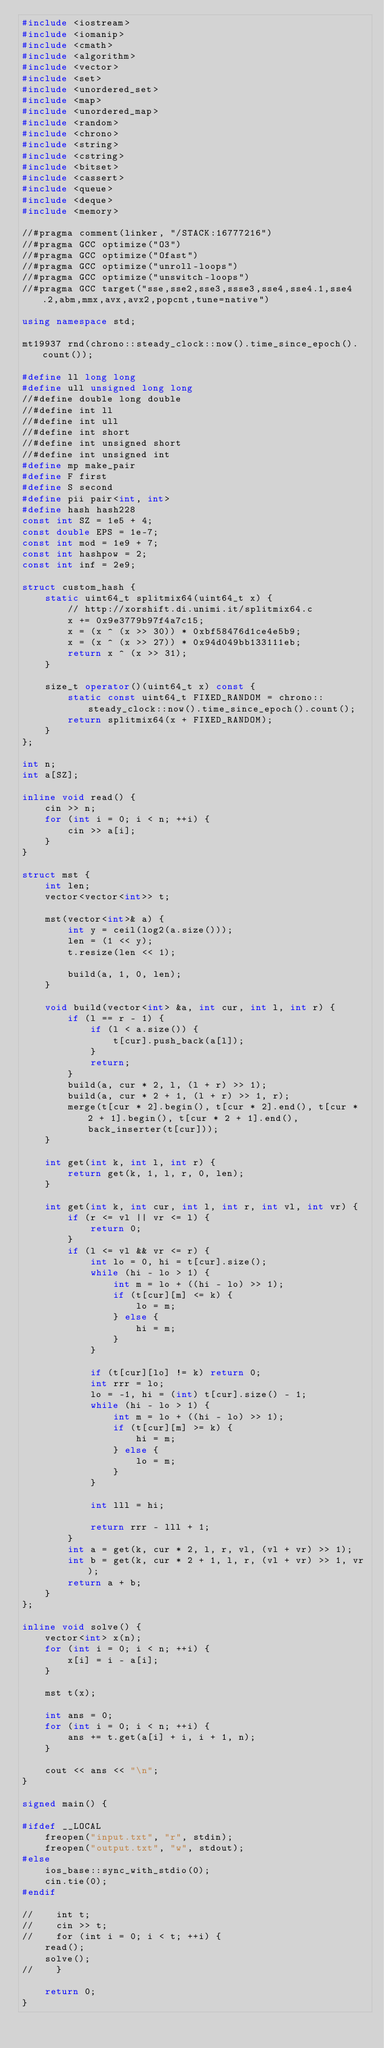<code> <loc_0><loc_0><loc_500><loc_500><_C++_>#include <iostream>
#include <iomanip>
#include <cmath>
#include <algorithm>
#include <vector>
#include <set>
#include <unordered_set>
#include <map>
#include <unordered_map>
#include <random>
#include <chrono>
#include <string>
#include <cstring>
#include <bitset>
#include <cassert>
#include <queue>
#include <deque>
#include <memory>

//#pragma comment(linker, "/STACK:16777216")
//#pragma GCC optimize("O3")
//#pragma GCC optimize("Ofast")
//#pragma GCC optimize("unroll-loops")
//#pragma GCC optimize("unswitch-loops")
//#pragma GCC target("sse,sse2,sse3,ssse3,sse4,sse4.1,sse4.2,abm,mmx,avx,avx2,popcnt,tune=native")

using namespace std;

mt19937 rnd(chrono::steady_clock::now().time_since_epoch().count());

#define ll long long
#define ull unsigned long long
//#define double long double
//#define int ll
//#define int ull
//#define int short
//#define int unsigned short
//#define int unsigned int
#define mp make_pair
#define F first
#define S second
#define pii pair<int, int>
#define hash hash228
const int SZ = 1e5 + 4;
const double EPS = 1e-7;
const int mod = 1e9 + 7;
const int hashpow = 2;
const int inf = 2e9;

struct custom_hash {
    static uint64_t splitmix64(uint64_t x) {
        // http://xorshift.di.unimi.it/splitmix64.c
        x += 0x9e3779b97f4a7c15;
        x = (x ^ (x >> 30)) * 0xbf58476d1ce4e5b9;
        x = (x ^ (x >> 27)) * 0x94d049bb133111eb;
        return x ^ (x >> 31);
    }

    size_t operator()(uint64_t x) const {
        static const uint64_t FIXED_RANDOM = chrono::steady_clock::now().time_since_epoch().count();
        return splitmix64(x + FIXED_RANDOM);
    }
};

int n;
int a[SZ];

inline void read() {
    cin >> n;
    for (int i = 0; i < n; ++i) {
        cin >> a[i];
    }
}

struct mst {
    int len;
    vector<vector<int>> t;

    mst(vector<int>& a) {
        int y = ceil(log2(a.size()));
        len = (1 << y);
        t.resize(len << 1);

        build(a, 1, 0, len);
    }

    void build(vector<int> &a, int cur, int l, int r) {
        if (l == r - 1) {
            if (l < a.size()) {
                t[cur].push_back(a[l]);
            }
            return;
        }
        build(a, cur * 2, l, (l + r) >> 1);
        build(a, cur * 2 + 1, (l + r) >> 1, r);
        merge(t[cur * 2].begin(), t[cur * 2].end(), t[cur * 2 + 1].begin(), t[cur * 2 + 1].end(), back_inserter(t[cur]));
    }

    int get(int k, int l, int r) {
        return get(k, 1, l, r, 0, len);
    }

    int get(int k, int cur, int l, int r, int vl, int vr) {
        if (r <= vl || vr <= l) {
            return 0;
        }
        if (l <= vl && vr <= r) {
            int lo = 0, hi = t[cur].size();
            while (hi - lo > 1) {
                int m = lo + ((hi - lo) >> 1);
                if (t[cur][m] <= k) {
                    lo = m;
                } else {
                    hi = m;
                }
            }

            if (t[cur][lo] != k) return 0;
            int rrr = lo;
            lo = -1, hi = (int) t[cur].size() - 1;
            while (hi - lo > 1) {
                int m = lo + ((hi - lo) >> 1);
                if (t[cur][m] >= k) {
                    hi = m;
                } else {
                    lo = m;
                }
            }

            int lll = hi;

            return rrr - lll + 1;
        }
        int a = get(k, cur * 2, l, r, vl, (vl + vr) >> 1);
        int b = get(k, cur * 2 + 1, l, r, (vl + vr) >> 1, vr);
        return a + b;
    }
};

inline void solve() {
    vector<int> x(n);
    for (int i = 0; i < n; ++i) {
        x[i] = i - a[i];
    }

    mst t(x);

    int ans = 0;
    for (int i = 0; i < n; ++i) {
        ans += t.get(a[i] + i, i + 1, n);
    }

    cout << ans << "\n";
}

signed main() {

#ifdef __LOCAL
    freopen("input.txt", "r", stdin);
    freopen("output.txt", "w", stdout);
#else
    ios_base::sync_with_stdio(0);
    cin.tie(0);
#endif

//    int t;
//    cin >> t;
//    for (int i = 0; i < t; ++i) {
    read();
    solve();
//    }

    return 0;
}</code> 